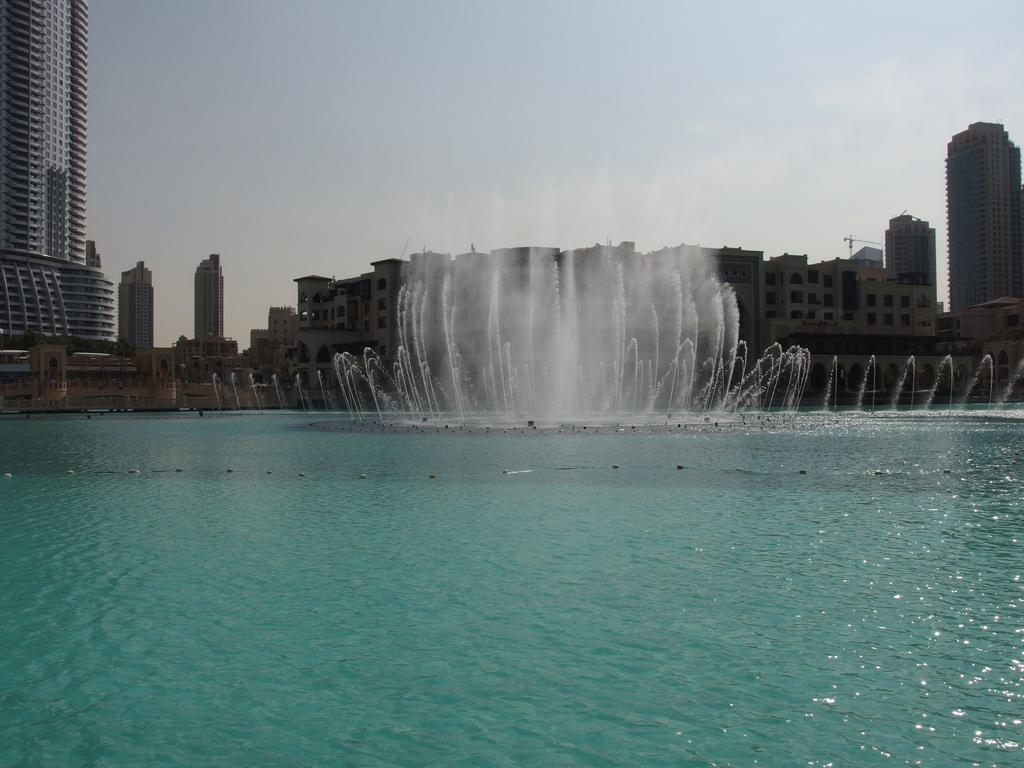What is the main feature in the image? There is a water fountain in the image. What is happening with the water in the fountain? Water is flowing in the fountain. What type of structure can be seen in the background? There is a skyscraper in the image. Are there any other buildings visible in the image? Yes, there are buildings in the image. What part of the natural environment is visible in the image? The sky is visible in the image. What type of stick can be seen leaning against the skyscraper in the image? There is no stick present in the image; it only features a water fountain, buildings, and the sky. Can you see any hills in the image? There are no hills visible in the image. 